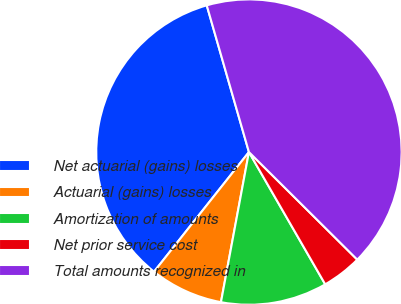<chart> <loc_0><loc_0><loc_500><loc_500><pie_chart><fcel>Net actuarial (gains) losses<fcel>Actuarial (gains) losses<fcel>Amortization of amounts<fcel>Net prior service cost<fcel>Total amounts recognized in<nl><fcel>34.87%<fcel>7.74%<fcel>11.26%<fcel>4.23%<fcel>41.9%<nl></chart> 